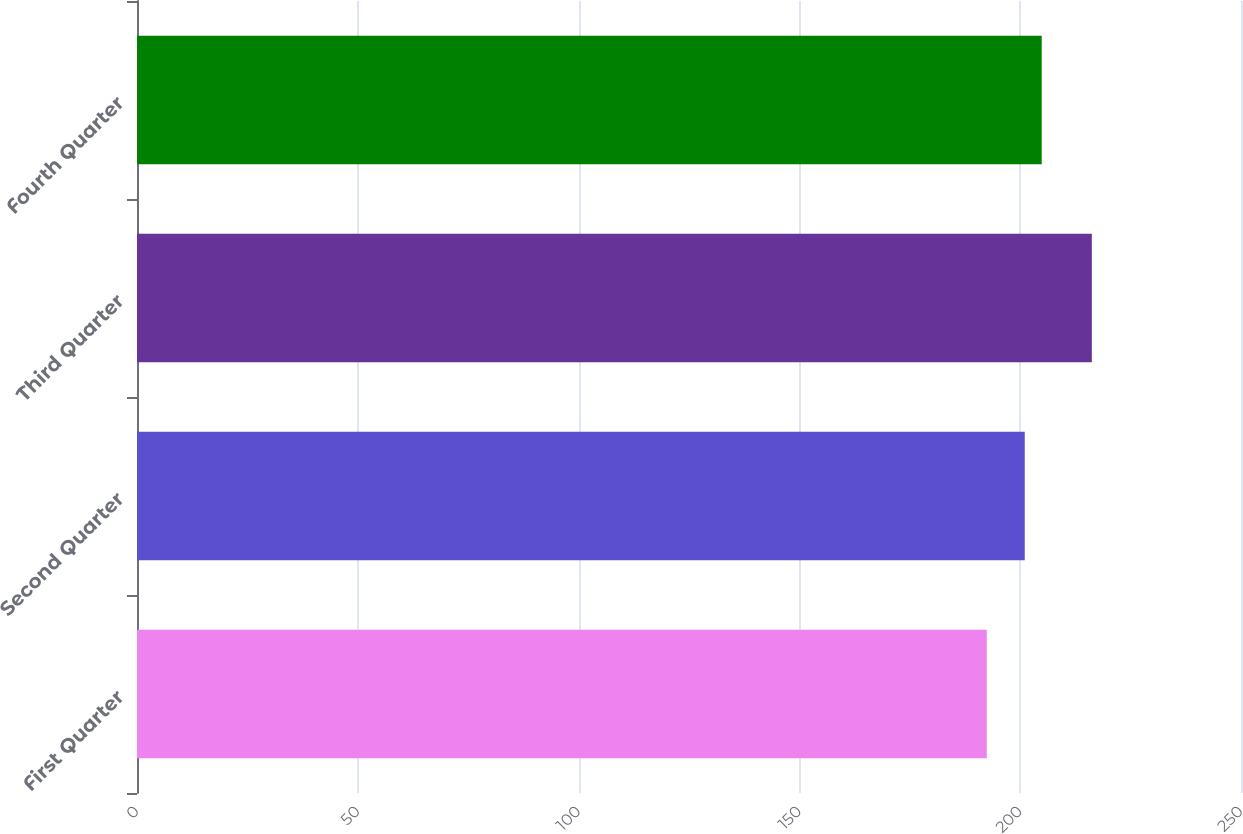Convert chart. <chart><loc_0><loc_0><loc_500><loc_500><bar_chart><fcel>First Quarter<fcel>Second Quarter<fcel>Third Quarter<fcel>Fourth Quarter<nl><fcel>192.43<fcel>201.03<fcel>216.22<fcel>204.87<nl></chart> 